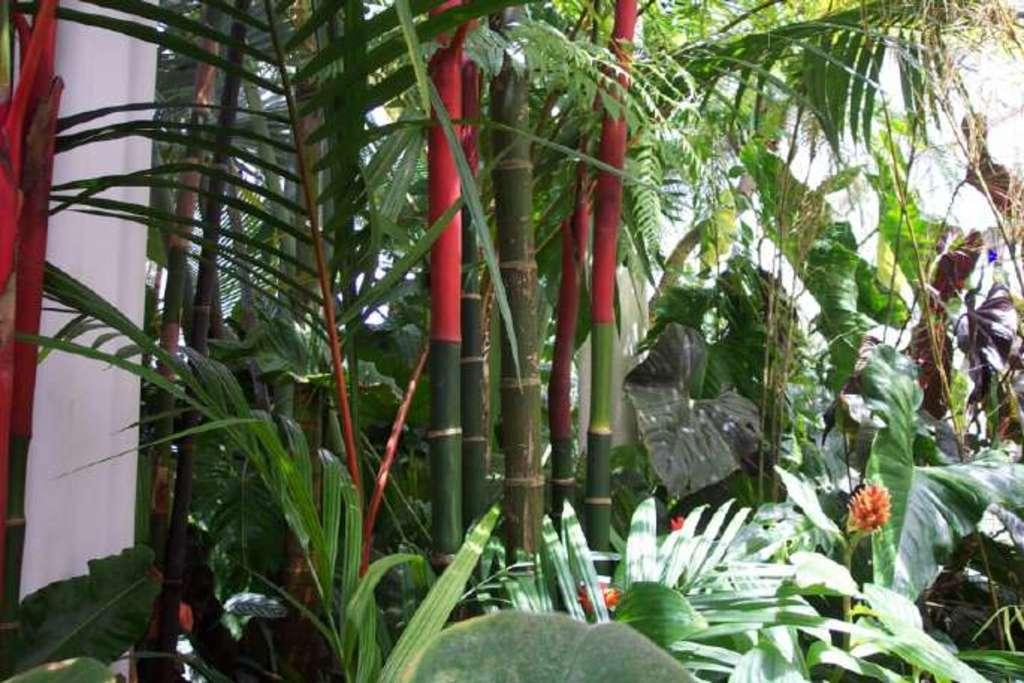What types of vegetation can be seen in the foreground of the image? There are many plants and flowers in the foreground of the image. Can you describe the wall on the left side of the image? The wall is on the left side of the image. What type of throne is visible in the image? There is no throne present in the image; it features plants, flowers, and a wall. 